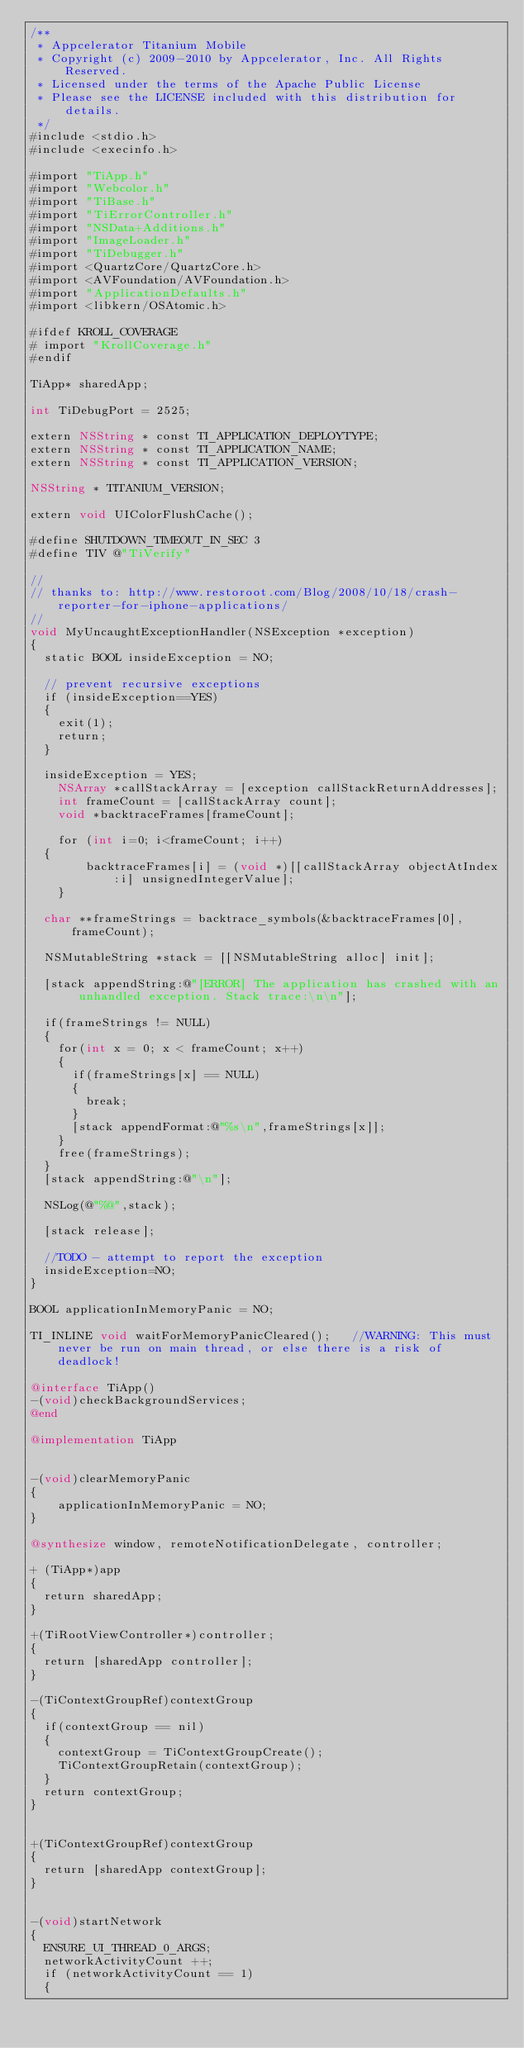<code> <loc_0><loc_0><loc_500><loc_500><_ObjectiveC_>/**
 * Appcelerator Titanium Mobile
 * Copyright (c) 2009-2010 by Appcelerator, Inc. All Rights Reserved.
 * Licensed under the terms of the Apache Public License
 * Please see the LICENSE included with this distribution for details.
 */
#include <stdio.h>
#include <execinfo.h>

#import "TiApp.h"
#import "Webcolor.h"
#import "TiBase.h"
#import "TiErrorController.h"
#import "NSData+Additions.h"
#import "ImageLoader.h"
#import "TiDebugger.h"
#import <QuartzCore/QuartzCore.h>
#import <AVFoundation/AVFoundation.h>
#import "ApplicationDefaults.h"
#import <libkern/OSAtomic.h>

#ifdef KROLL_COVERAGE
# import "KrollCoverage.h"
#endif

TiApp* sharedApp;

int TiDebugPort = 2525;

extern NSString * const TI_APPLICATION_DEPLOYTYPE;
extern NSString * const TI_APPLICATION_NAME;
extern NSString * const TI_APPLICATION_VERSION;

NSString * TITANIUM_VERSION;

extern void UIColorFlushCache();

#define SHUTDOWN_TIMEOUT_IN_SEC	3
#define TIV @"TiVerify"

//
// thanks to: http://www.restoroot.com/Blog/2008/10/18/crash-reporter-for-iphone-applications/
//
void MyUncaughtExceptionHandler(NSException *exception) 
{
	static BOOL insideException = NO;
	
	// prevent recursive exceptions
	if (insideException==YES)
	{
		exit(1);
		return;
	}
	
	insideException = YES;
    NSArray *callStackArray = [exception callStackReturnAddresses];
    int frameCount = [callStackArray count];
    void *backtraceFrames[frameCount];
	
    for (int i=0; i<frameCount; i++) 
	{
        backtraceFrames[i] = (void *)[[callStackArray objectAtIndex:i] unsignedIntegerValue];
    }
	
	char **frameStrings = backtrace_symbols(&backtraceFrames[0], frameCount);
	
	NSMutableString *stack = [[NSMutableString alloc] init];
	
	[stack appendString:@"[ERROR] The application has crashed with an unhandled exception. Stack trace:\n\n"];
	
	if(frameStrings != NULL) 
	{
		for(int x = 0; x < frameCount; x++) 
		{
			if(frameStrings[x] == NULL) 
			{ 
				break; 
			}
			[stack appendFormat:@"%s\n",frameStrings[x]];
		}
		free(frameStrings);
	}
	[stack appendString:@"\n"];
			 
	NSLog(@"%@",stack);
		
	[stack release];
	
	//TODO - attempt to report the exception
	insideException=NO;
}

BOOL applicationInMemoryPanic = NO;

TI_INLINE void waitForMemoryPanicCleared();   //WARNING: This must never be run on main thread, or else there is a risk of deadlock!

@interface TiApp()
-(void)checkBackgroundServices;
@end

@implementation TiApp


-(void)clearMemoryPanic
{
    applicationInMemoryPanic = NO;
}

@synthesize window, remoteNotificationDelegate, controller;

+ (TiApp*)app
{
	return sharedApp;
}

+(TiRootViewController*)controller;
{
	return [sharedApp controller];
}

-(TiContextGroupRef)contextGroup
{
	if(contextGroup == nil)
	{
		contextGroup = TiContextGroupCreate();
		TiContextGroupRetain(contextGroup);
	}
	return contextGroup;
}


+(TiContextGroupRef)contextGroup
{
	return [sharedApp contextGroup];
}


-(void)startNetwork
{
	ENSURE_UI_THREAD_0_ARGS;
	networkActivityCount ++;
	if (networkActivityCount == 1)
	{</code> 